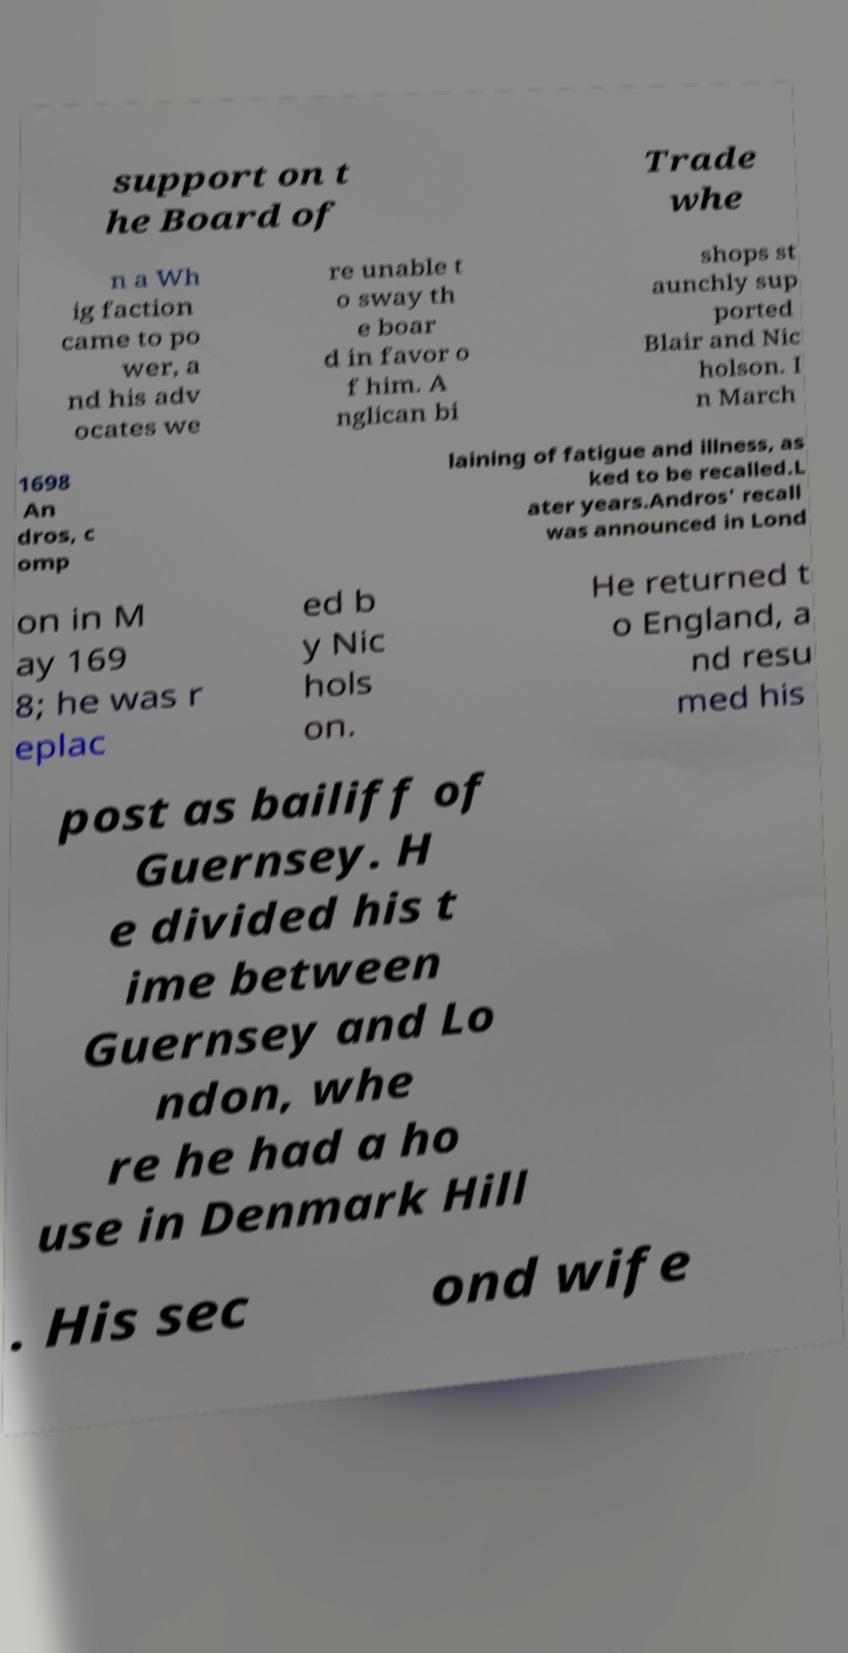There's text embedded in this image that I need extracted. Can you transcribe it verbatim? support on t he Board of Trade whe n a Wh ig faction came to po wer, a nd his adv ocates we re unable t o sway th e boar d in favor o f him. A nglican bi shops st aunchly sup ported Blair and Nic holson. I n March 1698 An dros, c omp laining of fatigue and illness, as ked to be recalled.L ater years.Andros' recall was announced in Lond on in M ay 169 8; he was r eplac ed b y Nic hols on. He returned t o England, a nd resu med his post as bailiff of Guernsey. H e divided his t ime between Guernsey and Lo ndon, whe re he had a ho use in Denmark Hill . His sec ond wife 